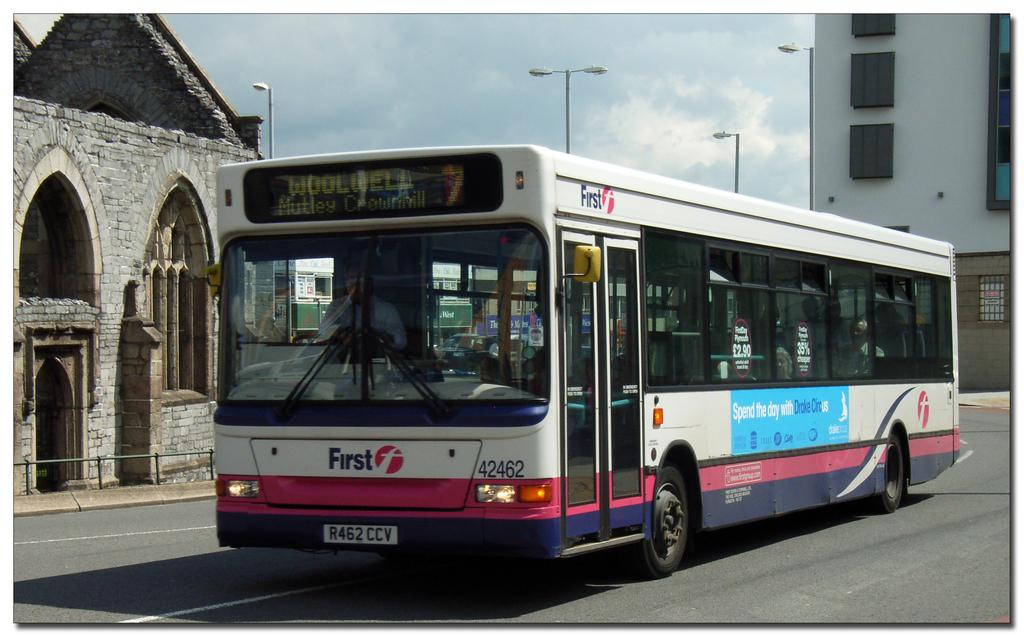What is the main subject of the image? The main subject of the image is a bus. What is the bus doing in the image? The bus is moving on the road. What else can be seen in the image besides the bus? There are buildings visible in the image. Can you see a group of people on a pan on the island in the image? There is no pan, group of people, or island present in the image; it features a bus moving on the road with buildings in the background. 